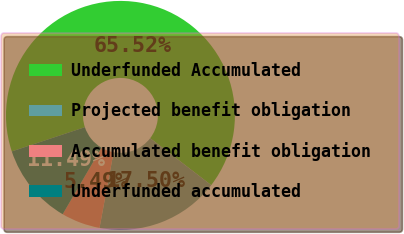Convert chart. <chart><loc_0><loc_0><loc_500><loc_500><pie_chart><fcel>Underfunded Accumulated<fcel>Projected benefit obligation<fcel>Accumulated benefit obligation<fcel>Underfunded accumulated<nl><fcel>65.53%<fcel>17.5%<fcel>5.49%<fcel>11.49%<nl></chart> 